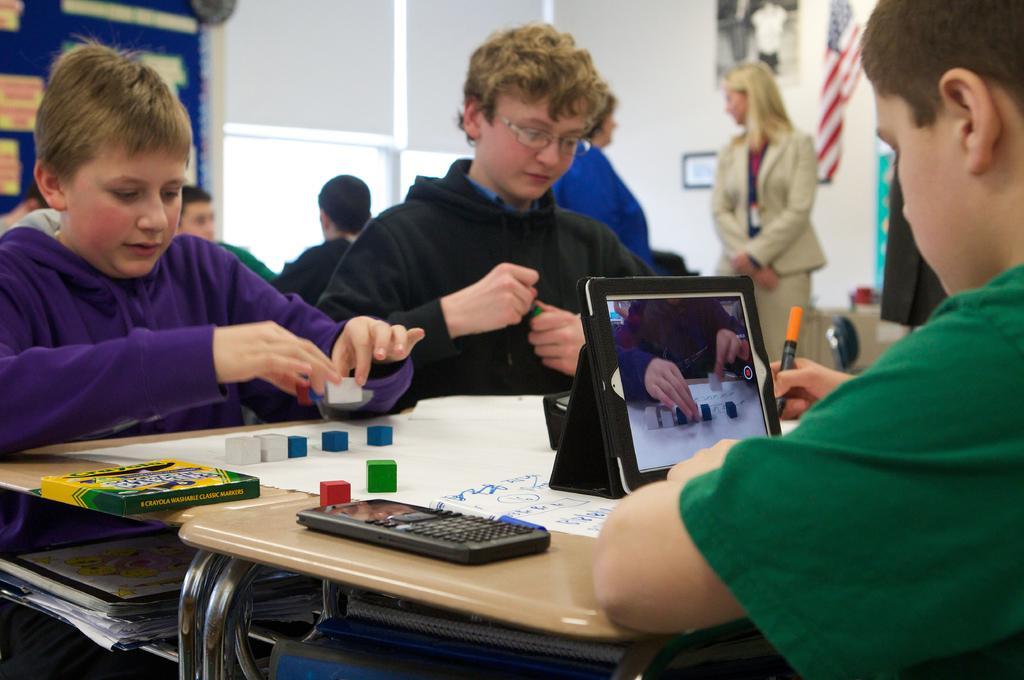In one or two sentences, can you explain what this image depicts? There are three persons sitting on the chairs. This is table. On the table there is a i pod, papers, box, and a calculator. Here we can see a woman standing on the floor. On the background there is a wall and this is flag. Here we can see a glass. 